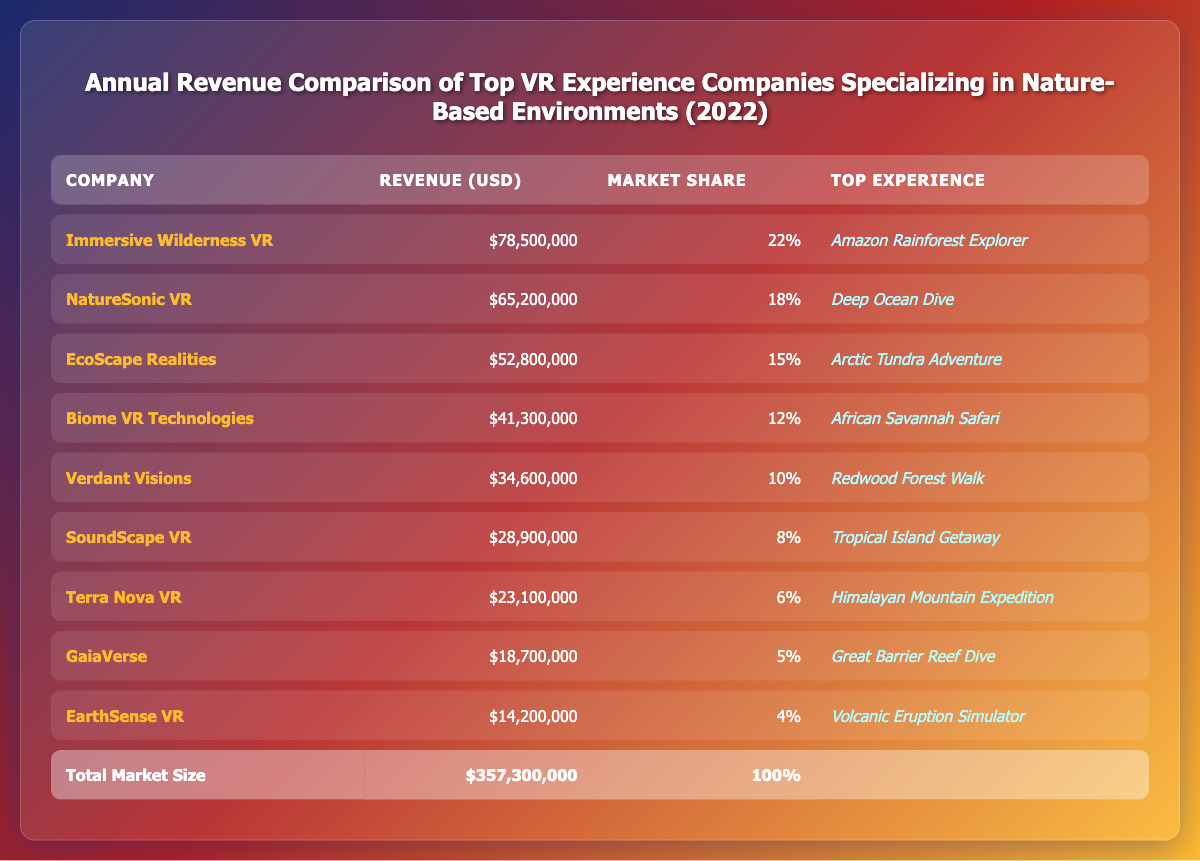What is the total revenue of Immersive Wilderness VR? The revenue column lists Immersive Wilderness VR's revenue directly as $78,500,000.
Answer: $78,500,000 Which company has the highest market share? Immersive Wilderness VR has the highest market share of 22%, which is higher than any other company listed.
Answer: Immersive Wilderness VR What is the average revenue of the top three companies? The revenues of the top three companies are $78,500,000, $65,200,000, and $52,800,000. Summing these gives $196,500,000. Dividing by 3, the average revenue is $196,500,000 / 3 = $65,500,000.
Answer: $65,500,000 Is NatureSonic VR's revenue more than $60 million? NatureSonic VR's revenue is listed as $65,200,000, which is greater than $60 million.
Answer: Yes What is the total revenue of the companies below the median revenue? The median revenue of the 9 companies is the 5th highest value, which is $34,600,000 (from Verdant Visions). The companies below this are SoundScape VR, Terra Nova VR, GaiaVerse, and EarthSense VR with revenues of $28,900,000, $23,100,000, $18,700,000, and $14,200,000. Their total revenue is $28,900,000 + $23,100,000 + $18,700,000 + $14,200,000 = $84,900,000.
Answer: $84,900,000 Which company generates the least revenue? EarthSense VR has the lowest revenue at $14,200,000, which is less than all other companies listed in the table.
Answer: EarthSense VR If the top two companies increased their revenues by 10%, what would be their new total revenue? Immersive Wilderness VR's revenue after a 10% increase is $78,500,000 * 1.1 = $86,350,000. NatureSonic VR's revenue becomes $65,200,000 * 1.1 = $71,720,000. Their new total revenue would be $86,350,000 + $71,720,000 = $158,070,000.
Answer: $158,070,000 What percentage of the total market size is EcoScape Realities' revenue? EcoScape Realities has a revenue of $52,800,000, and the total market size is $357,300,000. The percentage is calculated as ($52,800,000 / $357,300,000) * 100 ≈ 14.79%.
Answer: Approximately 14.79% Is the combined market share of the bottom three companies greater than 20%? The market shares of the bottom three companies (SoundScape VR, Terra Nova VR, GaiaVerse) are 8%, 6%, and 5%, respectively. Their combined market share is 8% + 6% + 5% = 19%, which is less than 20%.
Answer: No 